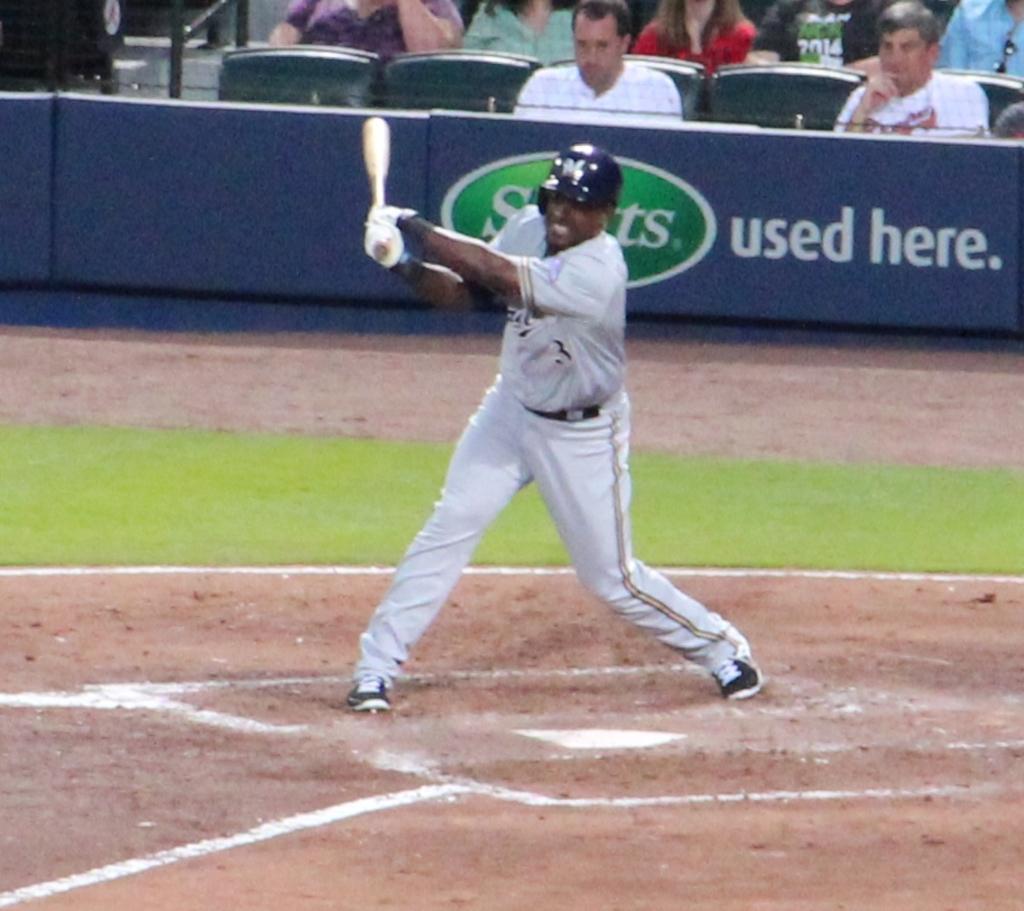Could you give a brief overview of what you see in this image? In the center of the image there is a person holding a baseball bat. He is wearing a helmet. In the background of the image there are people sitting on chairs. At the bottom of the image there is mud. There is grass in the image. 